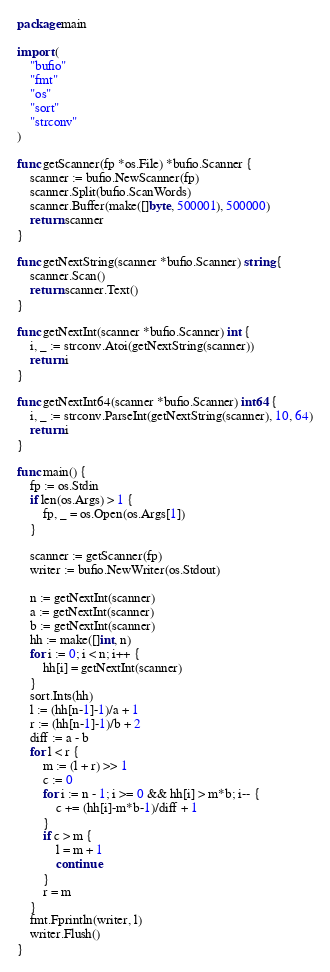<code> <loc_0><loc_0><loc_500><loc_500><_Go_>package main

import (
	"bufio"
	"fmt"
	"os"
	"sort"
	"strconv"
)

func getScanner(fp *os.File) *bufio.Scanner {
	scanner := bufio.NewScanner(fp)
	scanner.Split(bufio.ScanWords)
	scanner.Buffer(make([]byte, 500001), 500000)
	return scanner
}

func getNextString(scanner *bufio.Scanner) string {
	scanner.Scan()
	return scanner.Text()
}

func getNextInt(scanner *bufio.Scanner) int {
	i, _ := strconv.Atoi(getNextString(scanner))
	return i
}

func getNextInt64(scanner *bufio.Scanner) int64 {
	i, _ := strconv.ParseInt(getNextString(scanner), 10, 64)
	return i
}

func main() {
	fp := os.Stdin
	if len(os.Args) > 1 {
		fp, _ = os.Open(os.Args[1])
	}

	scanner := getScanner(fp)
	writer := bufio.NewWriter(os.Stdout)

	n := getNextInt(scanner)
	a := getNextInt(scanner)
	b := getNextInt(scanner)
	hh := make([]int, n)
	for i := 0; i < n; i++ {
		hh[i] = getNextInt(scanner)
	}
	sort.Ints(hh)
	l := (hh[n-1]-1)/a + 1
	r := (hh[n-1]-1)/b + 2
	diff := a - b
	for l < r {
		m := (l + r) >> 1
		c := 0
		for i := n - 1; i >= 0 && hh[i] > m*b; i-- {
			c += (hh[i]-m*b-1)/diff + 1
		}
		if c > m {
			l = m + 1
			continue
		}
		r = m
	}
	fmt.Fprintln(writer, l)
	writer.Flush()
}
</code> 